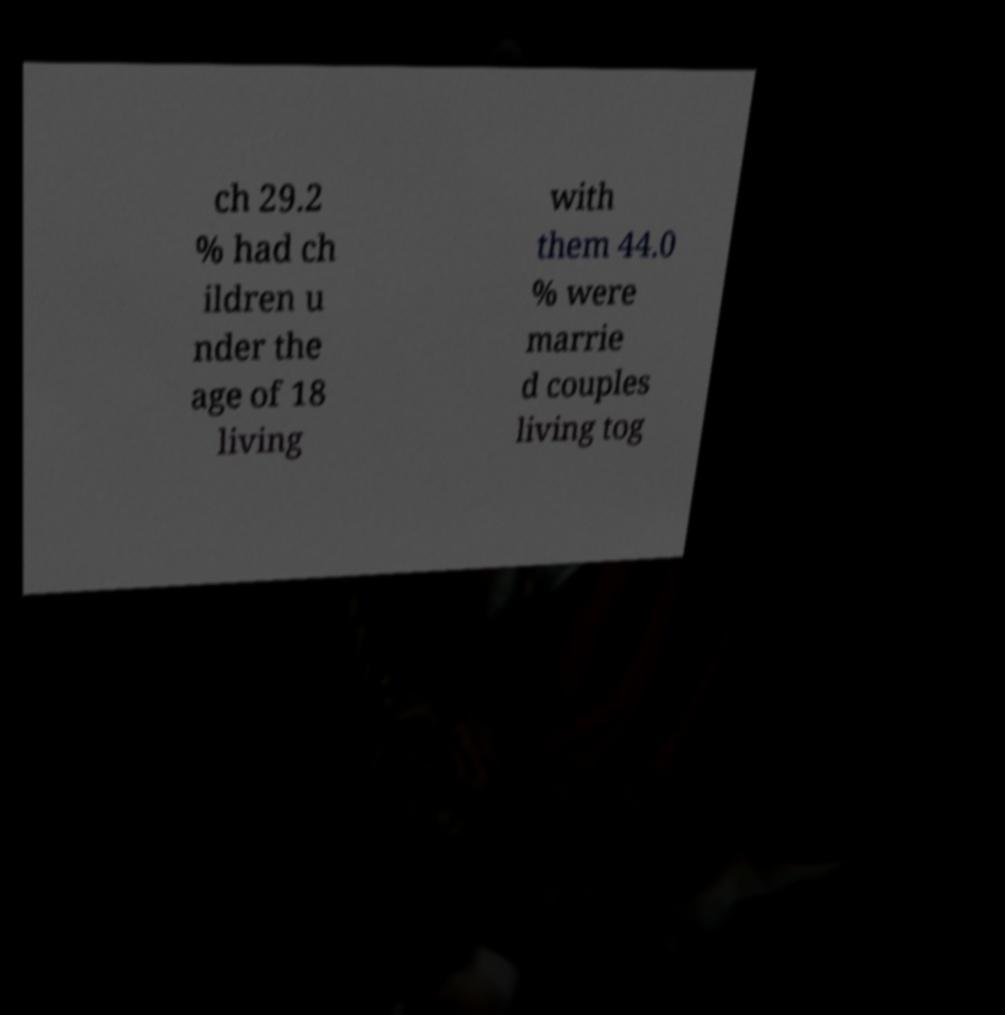I need the written content from this picture converted into text. Can you do that? ch 29.2 % had ch ildren u nder the age of 18 living with them 44.0 % were marrie d couples living tog 